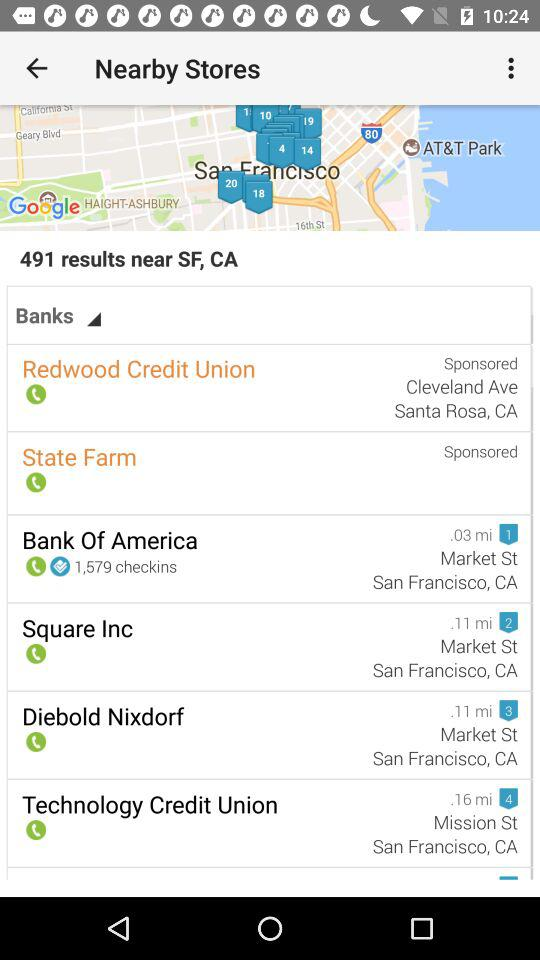How many results are there in the vicinity of SF, CA? There are 491 results. 